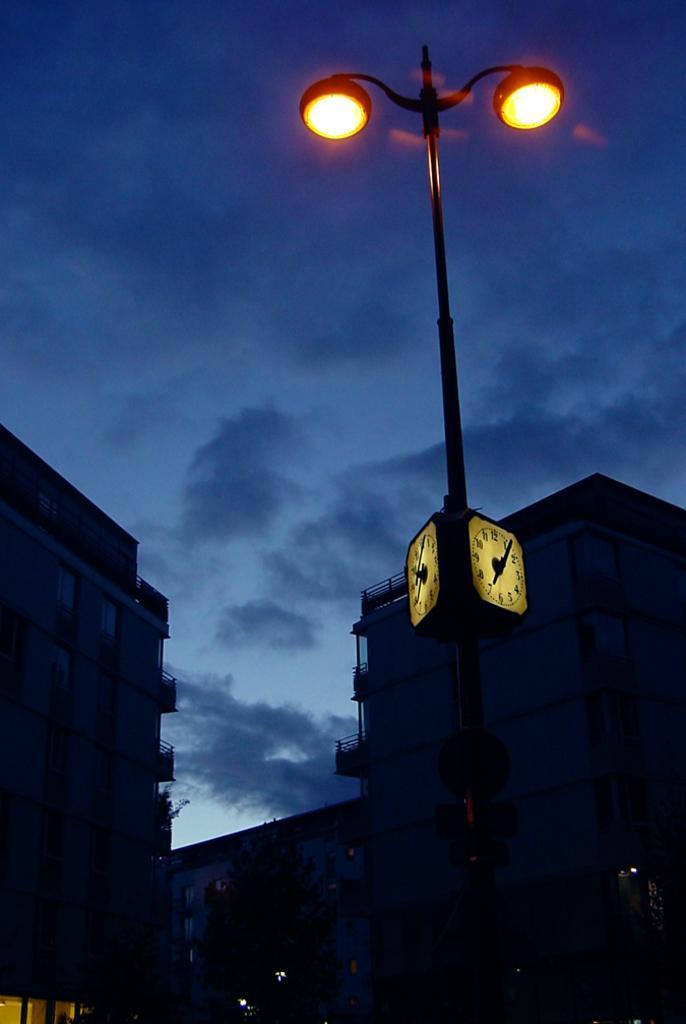Please provide a concise description of this image. In this picture we can see street lights and clocks on a pole. We can see a tree, buildings, other objects and the cloudy sky. 